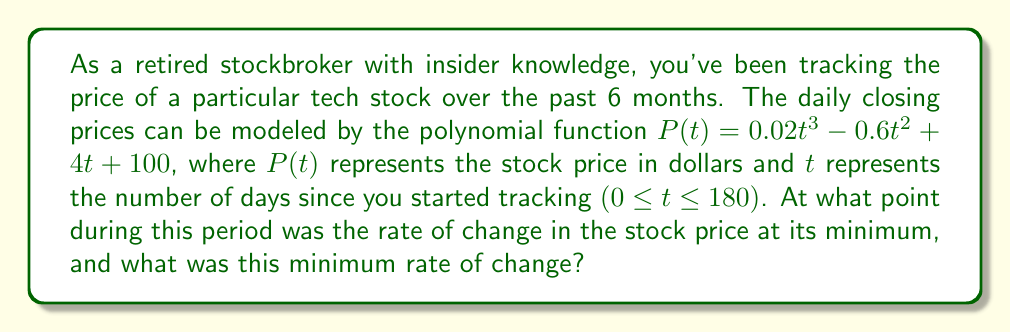Give your solution to this math problem. To solve this problem, we need to follow these steps:

1) The rate of change of the stock price is given by the first derivative of $P(t)$:

   $$P'(t) = 0.06t^2 - 1.2t + 4$$

2) To find the minimum rate of change, we need to find where the second derivative equals zero:

   $$P''(t) = 0.12t - 1.2$$

3) Set $P''(t) = 0$ and solve for $t$:

   $$0.12t - 1.2 = 0$$
   $$0.12t = 1.2$$
   $$t = 10$$

4) To confirm this is a minimum (not a maximum), check that $P'''(t) > 0$:

   $$P'''(t) = 0.12 > 0$$

5) Therefore, the minimum rate of change occurs at $t = 10$ days.

6) To find the minimum rate of change, substitute $t = 10$ into $P'(t)$:

   $$P'(10) = 0.06(10)^2 - 1.2(10) + 4$$
   $$= 6 - 12 + 4 = -2$$

Thus, the minimum rate of change is -2 dollars per day, occurring 10 days after you started tracking the stock.
Answer: The minimum rate of change occurs 10 days after tracking began, and the minimum rate of change is -$2 per day. 